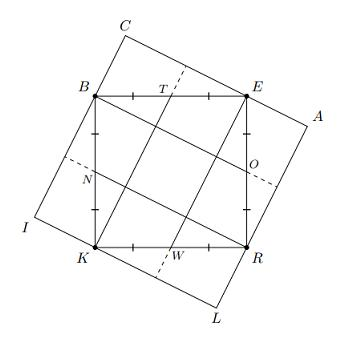What geometric properties are shared between square BERK and square CALI as observed in the image? Both square BERK and square CALI share similar geometric properties such as having equal side lengths and being oriented in a way that their vertices coincide. They both have parallel and equal-length opposite sides and right angles at each vertex. Additionally, the rotation of square CALI relative to BERK aligns the diagonals of one square with midpoints of another, indicating rotational symmetry around their center. 